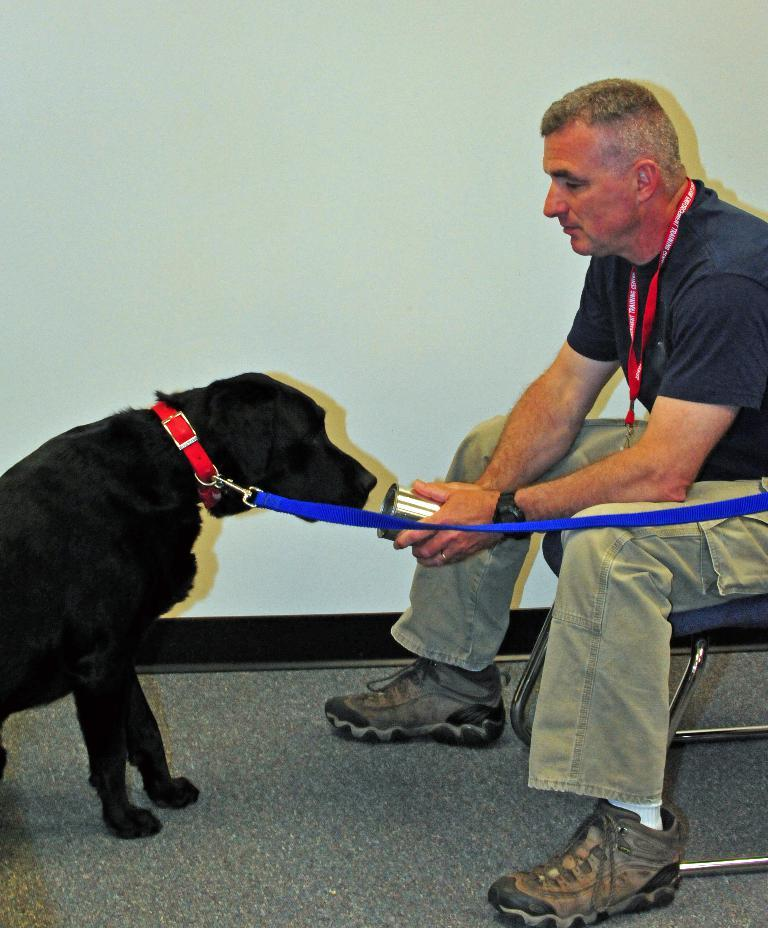What is the person in the image doing? The person is sitting on a chair on the right side of the image. What animal is present in the image? There is a dog on the left side of the image. What can be seen in the background of the image? There is a wall in the background of the image. What type of van is parked behind the person in the image? There is no van present in the image; it only features a person sitting on a chair, a dog, and a wall in the background. 